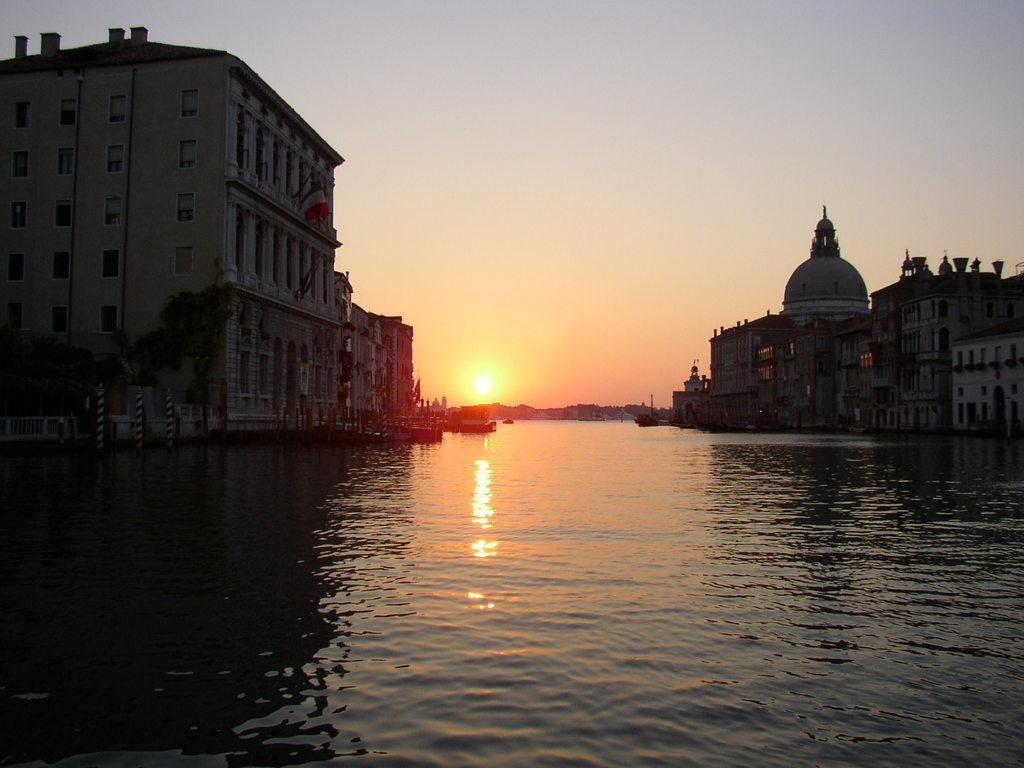What type of structures can be seen in the image? There are buildings in the image. What is located in the center of the image? There is water in the center of the image. What can be seen in the background of the image? The sky is visible in the background of the image. Can the sun be seen in the image? Yes, the sun is observable in the sky. How many cats are swimming in the water in the image? There are no cats present in the image, and therefore no cats can be seen swimming in the water. 